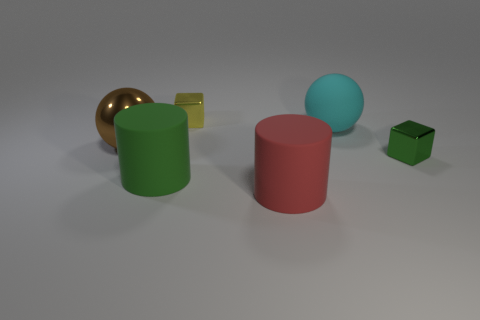Subtract all gray blocks. Subtract all brown spheres. How many blocks are left? 2 Add 1 big red metallic blocks. How many objects exist? 7 Subtract all spheres. How many objects are left? 4 Add 2 large cyan balls. How many large cyan balls exist? 3 Subtract 1 brown spheres. How many objects are left? 5 Subtract all small red metallic balls. Subtract all large brown spheres. How many objects are left? 5 Add 6 brown spheres. How many brown spheres are left? 7 